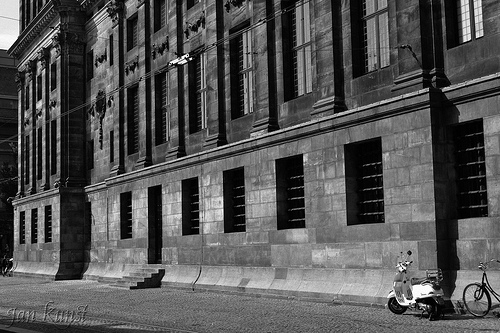On which side of the image is the bicycle? The bicycle is on the right side of the image. 